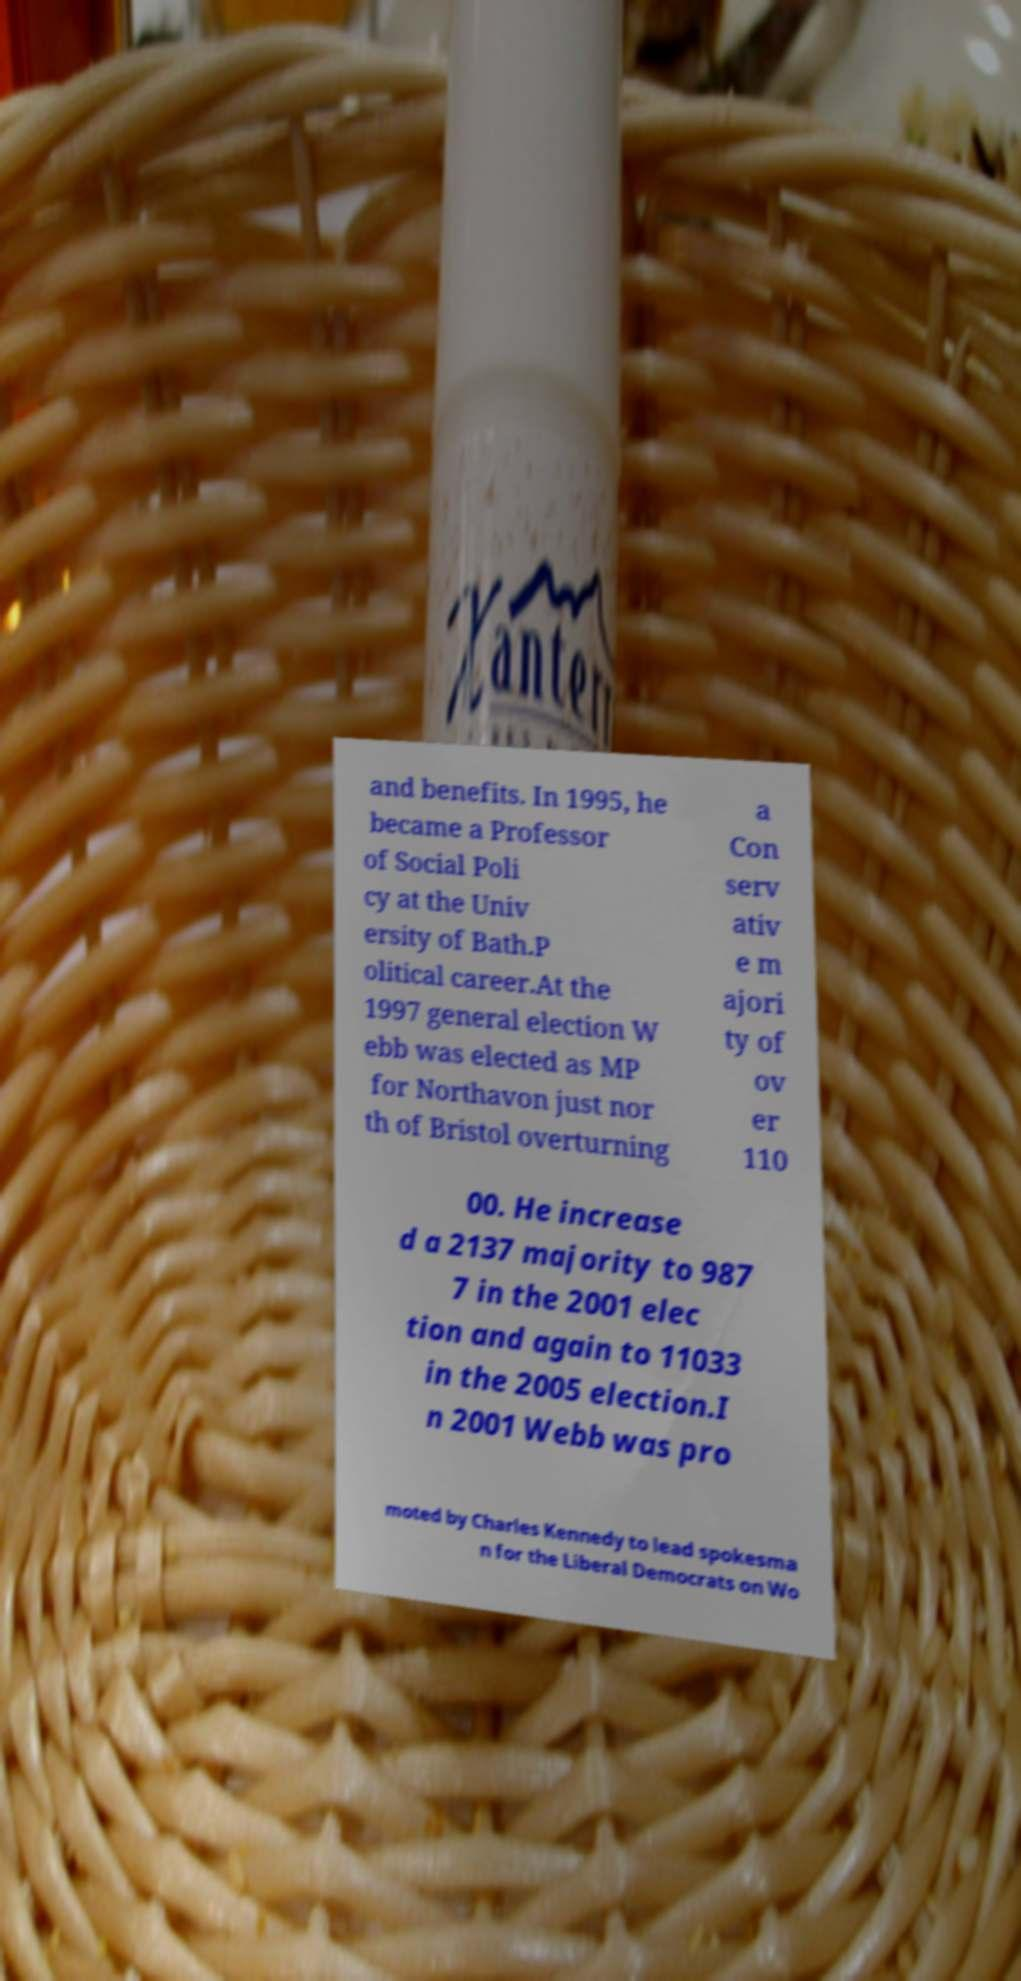What messages or text are displayed in this image? I need them in a readable, typed format. and benefits. In 1995, he became a Professor of Social Poli cy at the Univ ersity of Bath.P olitical career.At the 1997 general election W ebb was elected as MP for Northavon just nor th of Bristol overturning a Con serv ativ e m ajori ty of ov er 110 00. He increase d a 2137 majority to 987 7 in the 2001 elec tion and again to 11033 in the 2005 election.I n 2001 Webb was pro moted by Charles Kennedy to lead spokesma n for the Liberal Democrats on Wo 